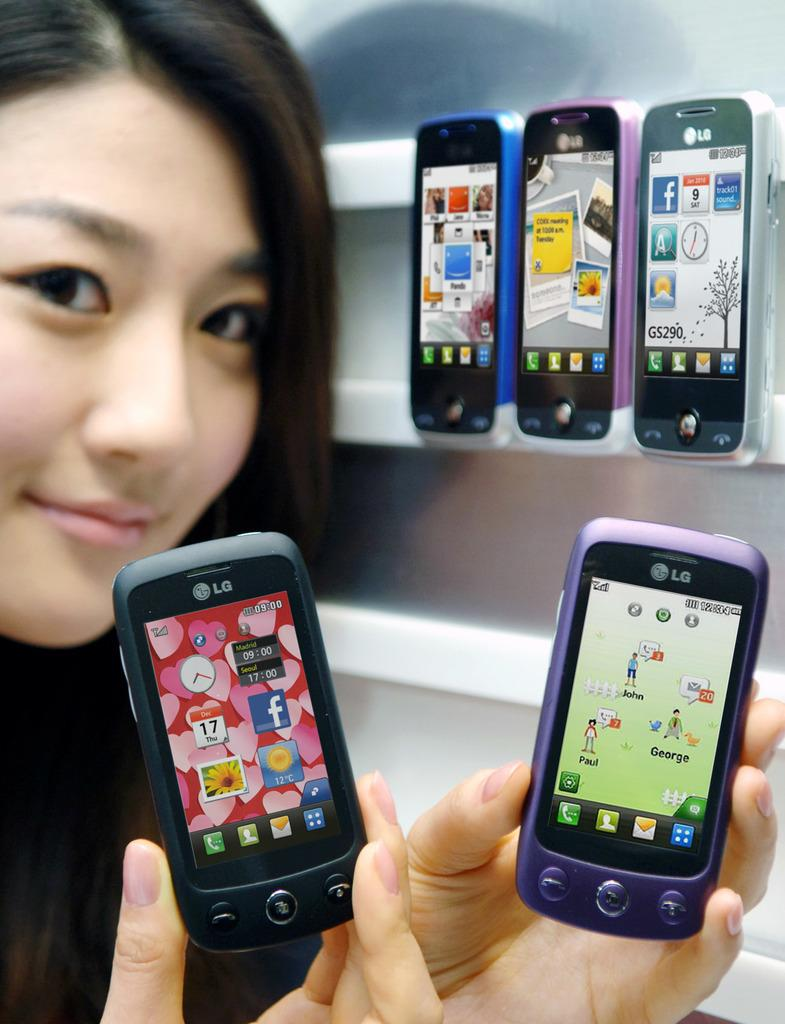Provide a one-sentence caption for the provided image. A woman holding LG phones that are purple and black. 